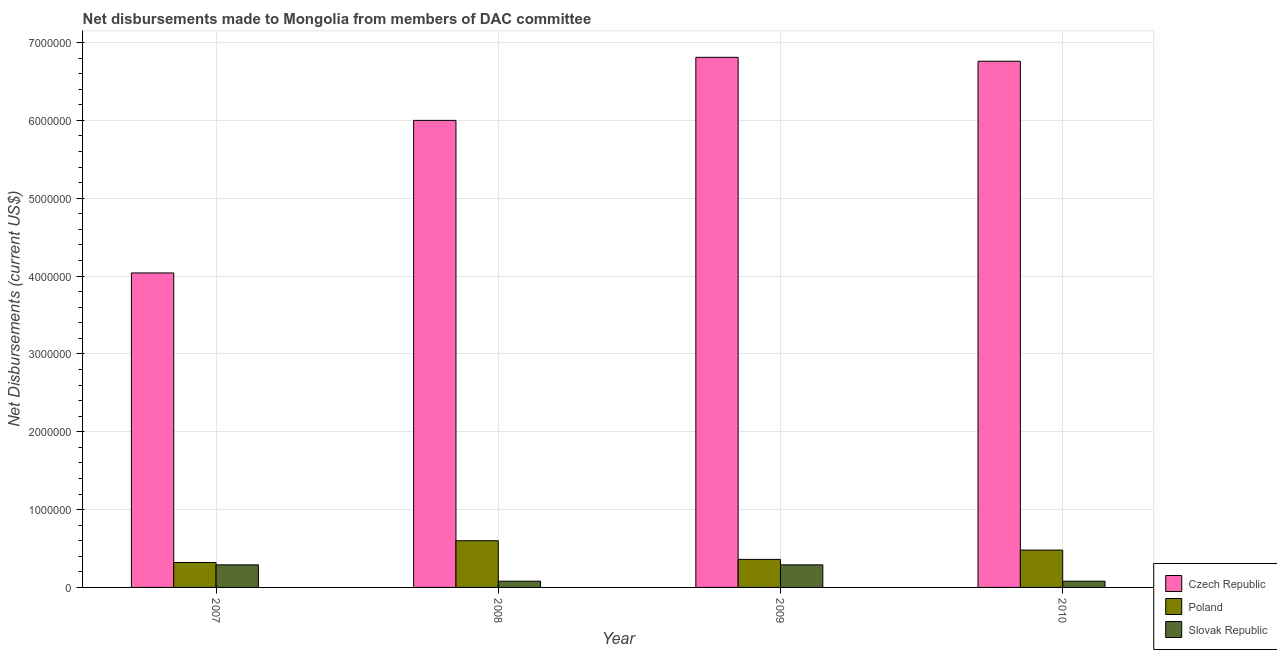How many groups of bars are there?
Offer a terse response. 4. Are the number of bars on each tick of the X-axis equal?
Give a very brief answer. Yes. What is the label of the 4th group of bars from the left?
Keep it short and to the point. 2010. In how many cases, is the number of bars for a given year not equal to the number of legend labels?
Provide a short and direct response. 0. What is the net disbursements made by czech republic in 2009?
Offer a terse response. 6.81e+06. Across all years, what is the maximum net disbursements made by czech republic?
Your answer should be very brief. 6.81e+06. Across all years, what is the minimum net disbursements made by czech republic?
Make the answer very short. 4.04e+06. In which year was the net disbursements made by slovak republic maximum?
Your response must be concise. 2007. In which year was the net disbursements made by czech republic minimum?
Offer a terse response. 2007. What is the total net disbursements made by poland in the graph?
Your answer should be very brief. 1.76e+06. What is the difference between the net disbursements made by czech republic in 2010 and the net disbursements made by slovak republic in 2008?
Ensure brevity in your answer.  7.60e+05. What is the average net disbursements made by czech republic per year?
Provide a succinct answer. 5.90e+06. In the year 2010, what is the difference between the net disbursements made by czech republic and net disbursements made by poland?
Provide a short and direct response. 0. What is the difference between the highest and the lowest net disbursements made by poland?
Your answer should be very brief. 2.80e+05. What does the 3rd bar from the left in 2009 represents?
Your answer should be compact. Slovak Republic. What does the 3rd bar from the right in 2008 represents?
Offer a terse response. Czech Republic. Is it the case that in every year, the sum of the net disbursements made by czech republic and net disbursements made by poland is greater than the net disbursements made by slovak republic?
Keep it short and to the point. Yes. What is the difference between two consecutive major ticks on the Y-axis?
Your response must be concise. 1.00e+06. Are the values on the major ticks of Y-axis written in scientific E-notation?
Offer a very short reply. No. Does the graph contain any zero values?
Offer a very short reply. No. Does the graph contain grids?
Provide a succinct answer. Yes. How are the legend labels stacked?
Your answer should be compact. Vertical. What is the title of the graph?
Ensure brevity in your answer.  Net disbursements made to Mongolia from members of DAC committee. What is the label or title of the Y-axis?
Your response must be concise. Net Disbursements (current US$). What is the Net Disbursements (current US$) of Czech Republic in 2007?
Provide a short and direct response. 4.04e+06. What is the Net Disbursements (current US$) in Slovak Republic in 2008?
Your answer should be very brief. 8.00e+04. What is the Net Disbursements (current US$) of Czech Republic in 2009?
Provide a succinct answer. 6.81e+06. What is the Net Disbursements (current US$) of Czech Republic in 2010?
Offer a terse response. 6.76e+06. What is the Net Disbursements (current US$) of Poland in 2010?
Make the answer very short. 4.80e+05. Across all years, what is the maximum Net Disbursements (current US$) in Czech Republic?
Offer a very short reply. 6.81e+06. Across all years, what is the maximum Net Disbursements (current US$) in Poland?
Keep it short and to the point. 6.00e+05. Across all years, what is the minimum Net Disbursements (current US$) in Czech Republic?
Your answer should be compact. 4.04e+06. Across all years, what is the minimum Net Disbursements (current US$) in Slovak Republic?
Keep it short and to the point. 8.00e+04. What is the total Net Disbursements (current US$) in Czech Republic in the graph?
Offer a very short reply. 2.36e+07. What is the total Net Disbursements (current US$) of Poland in the graph?
Ensure brevity in your answer.  1.76e+06. What is the total Net Disbursements (current US$) in Slovak Republic in the graph?
Ensure brevity in your answer.  7.40e+05. What is the difference between the Net Disbursements (current US$) of Czech Republic in 2007 and that in 2008?
Provide a short and direct response. -1.96e+06. What is the difference between the Net Disbursements (current US$) in Poland in 2007 and that in 2008?
Make the answer very short. -2.80e+05. What is the difference between the Net Disbursements (current US$) in Czech Republic in 2007 and that in 2009?
Provide a succinct answer. -2.77e+06. What is the difference between the Net Disbursements (current US$) of Slovak Republic in 2007 and that in 2009?
Ensure brevity in your answer.  0. What is the difference between the Net Disbursements (current US$) in Czech Republic in 2007 and that in 2010?
Provide a succinct answer. -2.72e+06. What is the difference between the Net Disbursements (current US$) in Poland in 2007 and that in 2010?
Ensure brevity in your answer.  -1.60e+05. What is the difference between the Net Disbursements (current US$) in Slovak Republic in 2007 and that in 2010?
Provide a succinct answer. 2.10e+05. What is the difference between the Net Disbursements (current US$) in Czech Republic in 2008 and that in 2009?
Ensure brevity in your answer.  -8.10e+05. What is the difference between the Net Disbursements (current US$) in Czech Republic in 2008 and that in 2010?
Your answer should be compact. -7.60e+05. What is the difference between the Net Disbursements (current US$) in Poland in 2008 and that in 2010?
Provide a short and direct response. 1.20e+05. What is the difference between the Net Disbursements (current US$) of Slovak Republic in 2009 and that in 2010?
Make the answer very short. 2.10e+05. What is the difference between the Net Disbursements (current US$) in Czech Republic in 2007 and the Net Disbursements (current US$) in Poland in 2008?
Provide a short and direct response. 3.44e+06. What is the difference between the Net Disbursements (current US$) of Czech Republic in 2007 and the Net Disbursements (current US$) of Slovak Republic in 2008?
Offer a very short reply. 3.96e+06. What is the difference between the Net Disbursements (current US$) of Czech Republic in 2007 and the Net Disbursements (current US$) of Poland in 2009?
Offer a terse response. 3.68e+06. What is the difference between the Net Disbursements (current US$) in Czech Republic in 2007 and the Net Disbursements (current US$) in Slovak Republic in 2009?
Provide a succinct answer. 3.75e+06. What is the difference between the Net Disbursements (current US$) in Poland in 2007 and the Net Disbursements (current US$) in Slovak Republic in 2009?
Keep it short and to the point. 3.00e+04. What is the difference between the Net Disbursements (current US$) of Czech Republic in 2007 and the Net Disbursements (current US$) of Poland in 2010?
Keep it short and to the point. 3.56e+06. What is the difference between the Net Disbursements (current US$) in Czech Republic in 2007 and the Net Disbursements (current US$) in Slovak Republic in 2010?
Your answer should be compact. 3.96e+06. What is the difference between the Net Disbursements (current US$) in Poland in 2007 and the Net Disbursements (current US$) in Slovak Republic in 2010?
Your answer should be compact. 2.40e+05. What is the difference between the Net Disbursements (current US$) in Czech Republic in 2008 and the Net Disbursements (current US$) in Poland in 2009?
Provide a short and direct response. 5.64e+06. What is the difference between the Net Disbursements (current US$) in Czech Republic in 2008 and the Net Disbursements (current US$) in Slovak Republic in 2009?
Ensure brevity in your answer.  5.71e+06. What is the difference between the Net Disbursements (current US$) in Poland in 2008 and the Net Disbursements (current US$) in Slovak Republic in 2009?
Make the answer very short. 3.10e+05. What is the difference between the Net Disbursements (current US$) of Czech Republic in 2008 and the Net Disbursements (current US$) of Poland in 2010?
Make the answer very short. 5.52e+06. What is the difference between the Net Disbursements (current US$) of Czech Republic in 2008 and the Net Disbursements (current US$) of Slovak Republic in 2010?
Ensure brevity in your answer.  5.92e+06. What is the difference between the Net Disbursements (current US$) in Poland in 2008 and the Net Disbursements (current US$) in Slovak Republic in 2010?
Make the answer very short. 5.20e+05. What is the difference between the Net Disbursements (current US$) in Czech Republic in 2009 and the Net Disbursements (current US$) in Poland in 2010?
Give a very brief answer. 6.33e+06. What is the difference between the Net Disbursements (current US$) in Czech Republic in 2009 and the Net Disbursements (current US$) in Slovak Republic in 2010?
Make the answer very short. 6.73e+06. What is the average Net Disbursements (current US$) in Czech Republic per year?
Give a very brief answer. 5.90e+06. What is the average Net Disbursements (current US$) in Slovak Republic per year?
Offer a terse response. 1.85e+05. In the year 2007, what is the difference between the Net Disbursements (current US$) of Czech Republic and Net Disbursements (current US$) of Poland?
Your answer should be compact. 3.72e+06. In the year 2007, what is the difference between the Net Disbursements (current US$) in Czech Republic and Net Disbursements (current US$) in Slovak Republic?
Your answer should be compact. 3.75e+06. In the year 2007, what is the difference between the Net Disbursements (current US$) of Poland and Net Disbursements (current US$) of Slovak Republic?
Ensure brevity in your answer.  3.00e+04. In the year 2008, what is the difference between the Net Disbursements (current US$) in Czech Republic and Net Disbursements (current US$) in Poland?
Ensure brevity in your answer.  5.40e+06. In the year 2008, what is the difference between the Net Disbursements (current US$) in Czech Republic and Net Disbursements (current US$) in Slovak Republic?
Ensure brevity in your answer.  5.92e+06. In the year 2008, what is the difference between the Net Disbursements (current US$) in Poland and Net Disbursements (current US$) in Slovak Republic?
Your answer should be compact. 5.20e+05. In the year 2009, what is the difference between the Net Disbursements (current US$) in Czech Republic and Net Disbursements (current US$) in Poland?
Keep it short and to the point. 6.45e+06. In the year 2009, what is the difference between the Net Disbursements (current US$) of Czech Republic and Net Disbursements (current US$) of Slovak Republic?
Your answer should be compact. 6.52e+06. In the year 2009, what is the difference between the Net Disbursements (current US$) in Poland and Net Disbursements (current US$) in Slovak Republic?
Offer a very short reply. 7.00e+04. In the year 2010, what is the difference between the Net Disbursements (current US$) of Czech Republic and Net Disbursements (current US$) of Poland?
Your response must be concise. 6.28e+06. In the year 2010, what is the difference between the Net Disbursements (current US$) in Czech Republic and Net Disbursements (current US$) in Slovak Republic?
Your response must be concise. 6.68e+06. In the year 2010, what is the difference between the Net Disbursements (current US$) of Poland and Net Disbursements (current US$) of Slovak Republic?
Give a very brief answer. 4.00e+05. What is the ratio of the Net Disbursements (current US$) in Czech Republic in 2007 to that in 2008?
Ensure brevity in your answer.  0.67. What is the ratio of the Net Disbursements (current US$) in Poland in 2007 to that in 2008?
Offer a terse response. 0.53. What is the ratio of the Net Disbursements (current US$) in Slovak Republic in 2007 to that in 2008?
Ensure brevity in your answer.  3.62. What is the ratio of the Net Disbursements (current US$) in Czech Republic in 2007 to that in 2009?
Ensure brevity in your answer.  0.59. What is the ratio of the Net Disbursements (current US$) in Poland in 2007 to that in 2009?
Keep it short and to the point. 0.89. What is the ratio of the Net Disbursements (current US$) of Czech Republic in 2007 to that in 2010?
Make the answer very short. 0.6. What is the ratio of the Net Disbursements (current US$) of Poland in 2007 to that in 2010?
Ensure brevity in your answer.  0.67. What is the ratio of the Net Disbursements (current US$) of Slovak Republic in 2007 to that in 2010?
Keep it short and to the point. 3.62. What is the ratio of the Net Disbursements (current US$) of Czech Republic in 2008 to that in 2009?
Offer a terse response. 0.88. What is the ratio of the Net Disbursements (current US$) in Poland in 2008 to that in 2009?
Offer a terse response. 1.67. What is the ratio of the Net Disbursements (current US$) of Slovak Republic in 2008 to that in 2009?
Your answer should be compact. 0.28. What is the ratio of the Net Disbursements (current US$) of Czech Republic in 2008 to that in 2010?
Ensure brevity in your answer.  0.89. What is the ratio of the Net Disbursements (current US$) of Czech Republic in 2009 to that in 2010?
Provide a short and direct response. 1.01. What is the ratio of the Net Disbursements (current US$) of Slovak Republic in 2009 to that in 2010?
Provide a succinct answer. 3.62. What is the difference between the highest and the lowest Net Disbursements (current US$) of Czech Republic?
Make the answer very short. 2.77e+06. What is the difference between the highest and the lowest Net Disbursements (current US$) in Poland?
Your answer should be compact. 2.80e+05. What is the difference between the highest and the lowest Net Disbursements (current US$) in Slovak Republic?
Provide a succinct answer. 2.10e+05. 